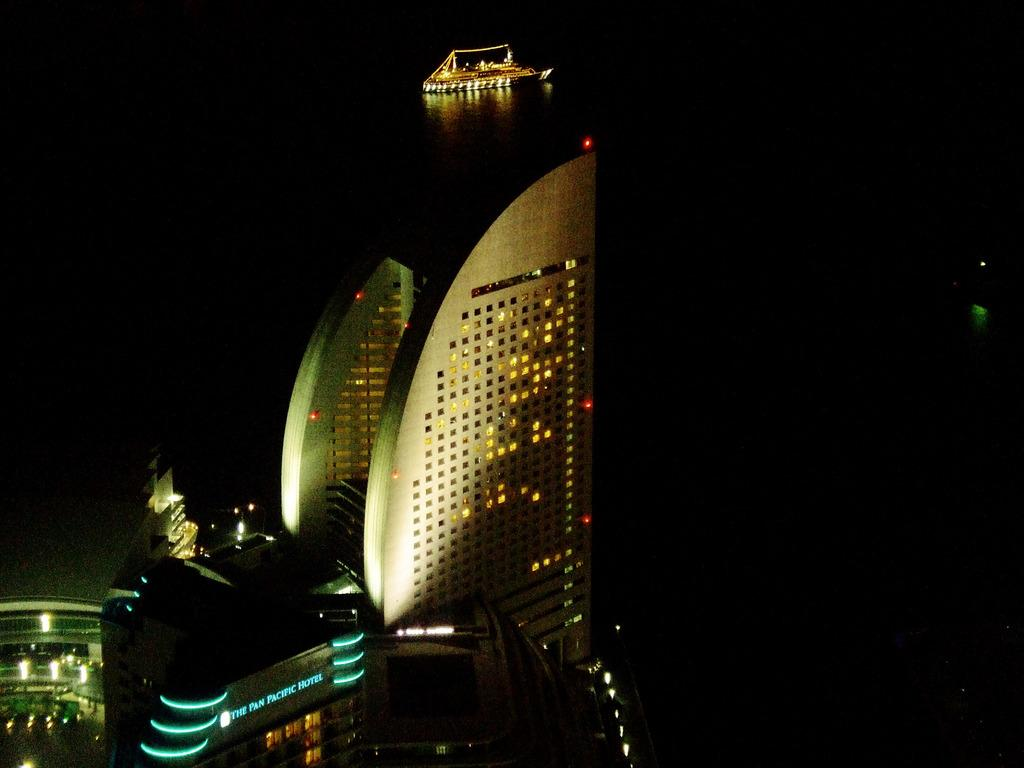Provide a one-sentence caption for the provided image. The Pan Pacific Hotel is seen lit up at night. 